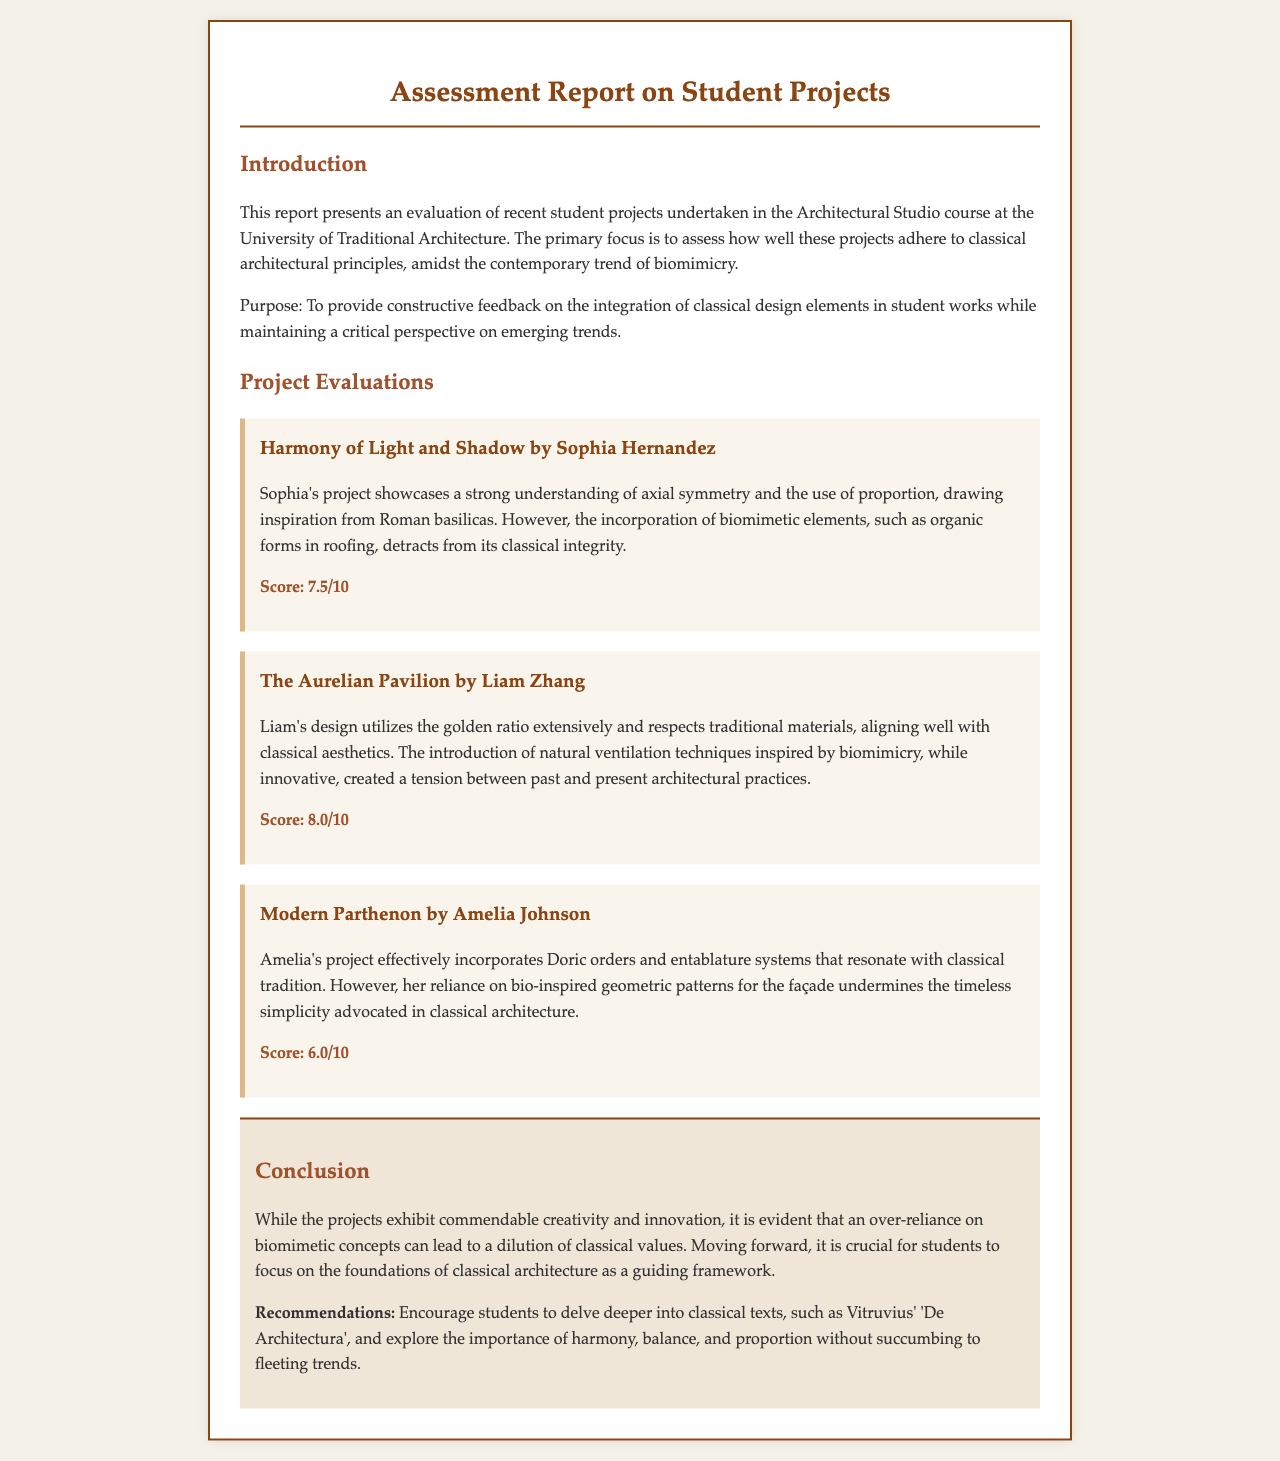What is the title of the report? The title is stated at the top of the document.
Answer: Assessment Report on Student Projects Who is the first project evaluated in the report? The first project is the one listed under Project Evaluations.
Answer: Harmony of Light and Shadow by Sophia Hernandez What score did Liam Zhang receive for his project? The score is mentioned below his project description.
Answer: 8.0/10 What architectural order is incorporated in Amelia Johnson's project? The architectural order is specified in the description of her project.
Answer: Doric orders What is the main concern raised in the conclusion about biomimicry? The main concern is highlighted in the concluding remarks.
Answer: Dilution of classical values What is one recommendation given to students in the conclusion? The recommendations are clearly outlined at the end of the report.
Answer: Delve deeper into classical texts What is the name of the second project evaluated? The name of the second project is mentioned in the project evaluations section.
Answer: The Aurelian Pavilion by Liam Zhang What design principle does Sophia Hernandez utilize in her project? The design principle is noted in the project description.
Answer: Axial symmetry and proportion 